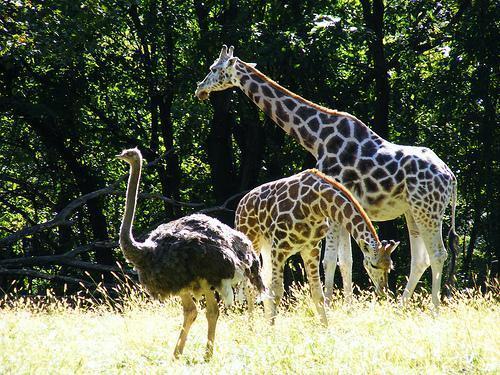How many giraffes are there?
Give a very brief answer. 2. 